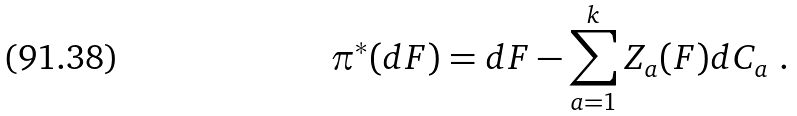Convert formula to latex. <formula><loc_0><loc_0><loc_500><loc_500>\pi ^ { * } ( d F ) = d F - \sum _ { a = 1 } ^ { k } Z _ { a } ( F ) d C _ { a } \ .</formula> 